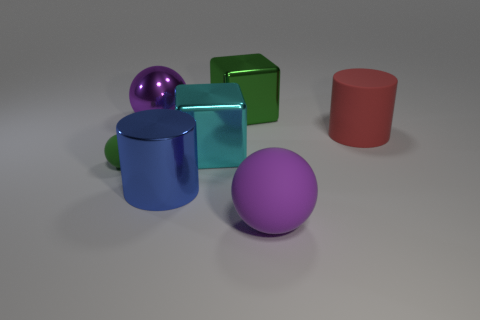Subtract all small green rubber balls. How many balls are left? 2 Subtract 3 spheres. How many spheres are left? 0 Add 1 big cyan shiny things. How many objects exist? 8 Subtract all green balls. How many balls are left? 2 Add 5 big balls. How many big balls exist? 7 Subtract 0 blue balls. How many objects are left? 7 Subtract all balls. How many objects are left? 4 Subtract all purple cylinders. Subtract all blue balls. How many cylinders are left? 2 Subtract all blue blocks. How many blue spheres are left? 0 Subtract all large metallic cylinders. Subtract all green rubber spheres. How many objects are left? 5 